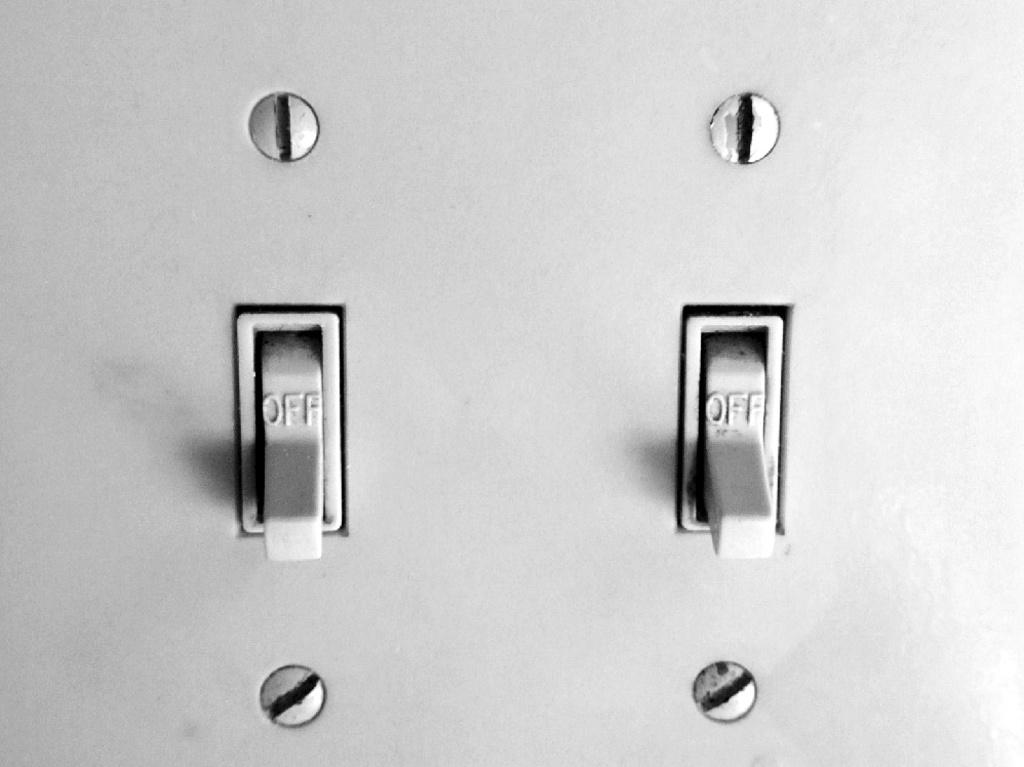<image>
Render a clear and concise summary of the photo. Two light switches are down, and say they are in the "OFF" position. 